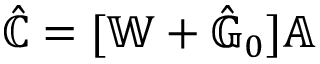Convert formula to latex. <formula><loc_0><loc_0><loc_500><loc_500>\hat { \mathbb { C } } = [ \mathbb { W } + { \hat { \mathbb { G } } } _ { 0 } ] \mathbb { A }</formula> 